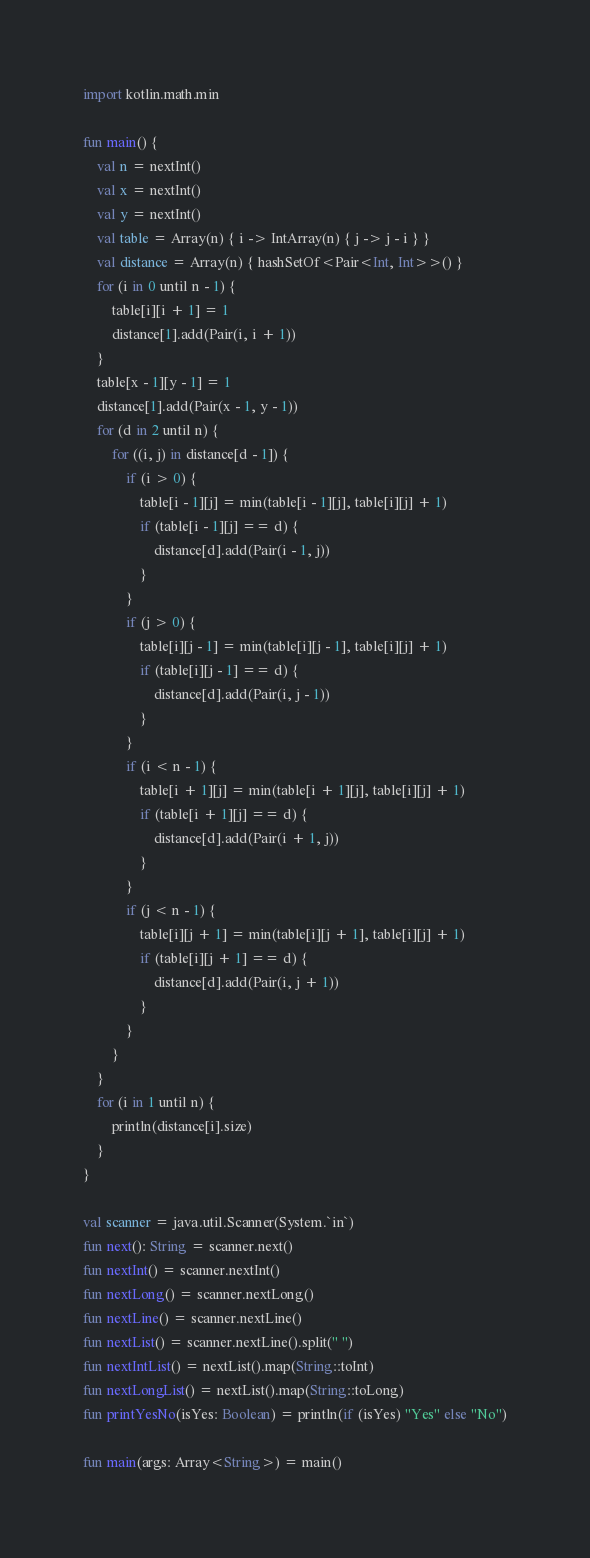<code> <loc_0><loc_0><loc_500><loc_500><_Kotlin_>import kotlin.math.min

fun main() {
    val n = nextInt()
    val x = nextInt()
    val y = nextInt()
    val table = Array(n) { i -> IntArray(n) { j -> j - i } }
    val distance = Array(n) { hashSetOf<Pair<Int, Int>>() }
    for (i in 0 until n - 1) {
        table[i][i + 1] = 1
        distance[1].add(Pair(i, i + 1))
    }
    table[x - 1][y - 1] = 1
    distance[1].add(Pair(x - 1, y - 1))
    for (d in 2 until n) {
        for ((i, j) in distance[d - 1]) {
            if (i > 0) {
                table[i - 1][j] = min(table[i - 1][j], table[i][j] + 1)
                if (table[i - 1][j] == d) {
                    distance[d].add(Pair(i - 1, j))
                }
            }
            if (j > 0) {
                table[i][j - 1] = min(table[i][j - 1], table[i][j] + 1)
                if (table[i][j - 1] == d) {
                    distance[d].add(Pair(i, j - 1))
                }
            }
            if (i < n - 1) {
                table[i + 1][j] = min(table[i + 1][j], table[i][j] + 1)
                if (table[i + 1][j] == d) {
                    distance[d].add(Pair(i + 1, j))
                }
            }
            if (j < n - 1) {
                table[i][j + 1] = min(table[i][j + 1], table[i][j] + 1)
                if (table[i][j + 1] == d) {
                    distance[d].add(Pair(i, j + 1))
                }
            }
        }
    }
    for (i in 1 until n) {
        println(distance[i].size)
    }
}

val scanner = java.util.Scanner(System.`in`)
fun next(): String = scanner.next()
fun nextInt() = scanner.nextInt()
fun nextLong() = scanner.nextLong()
fun nextLine() = scanner.nextLine()
fun nextList() = scanner.nextLine().split(" ")
fun nextIntList() = nextList().map(String::toInt)
fun nextLongList() = nextList().map(String::toLong)
fun printYesNo(isYes: Boolean) = println(if (isYes) "Yes" else "No")

fun main(args: Array<String>) = main()</code> 